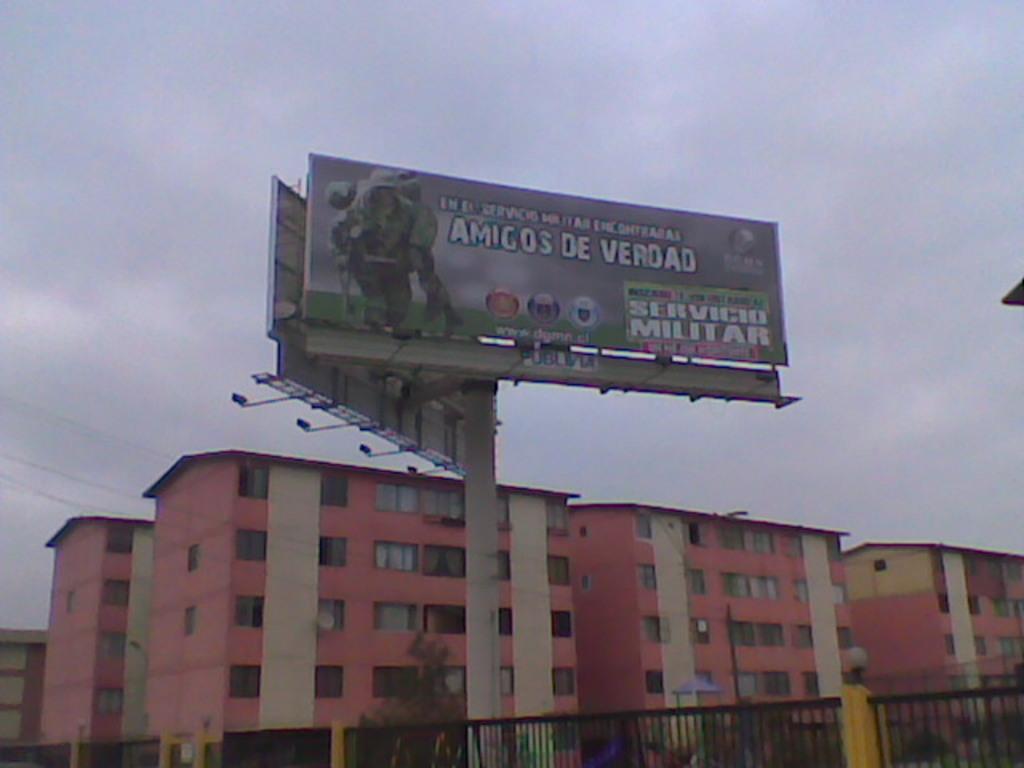What does the sign say?
Keep it short and to the point. Amigos de verdad. What is the title of the firm?
Provide a succinct answer. Amigos de verdad. 